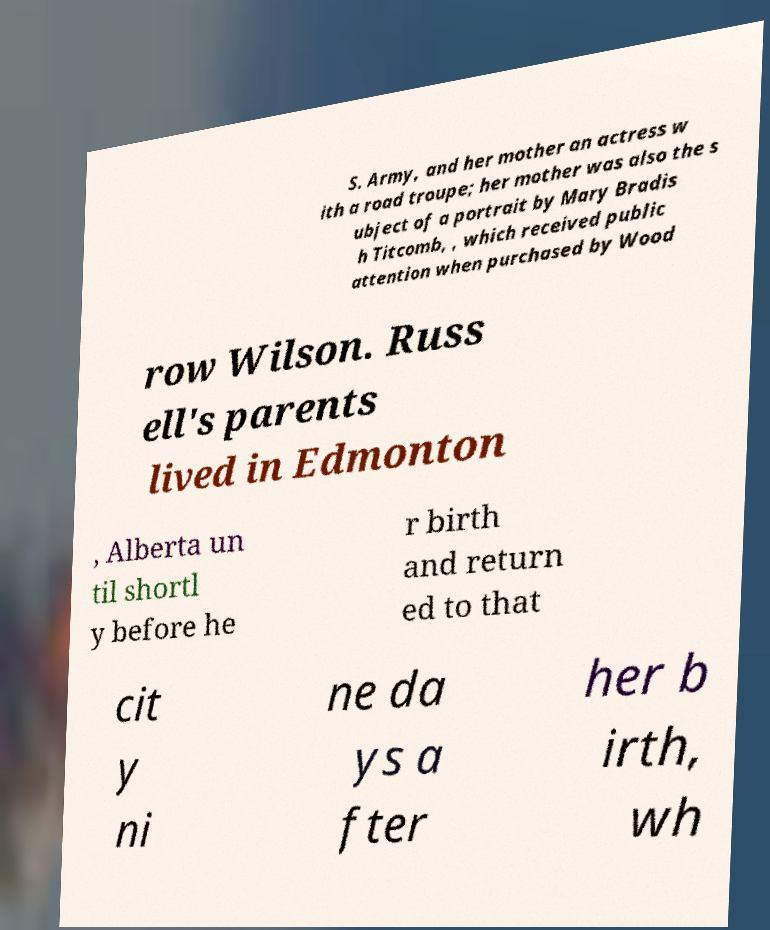Could you assist in decoding the text presented in this image and type it out clearly? S. Army, and her mother an actress w ith a road troupe; her mother was also the s ubject of a portrait by Mary Bradis h Titcomb, , which received public attention when purchased by Wood row Wilson. Russ ell's parents lived in Edmonton , Alberta un til shortl y before he r birth and return ed to that cit y ni ne da ys a fter her b irth, wh 